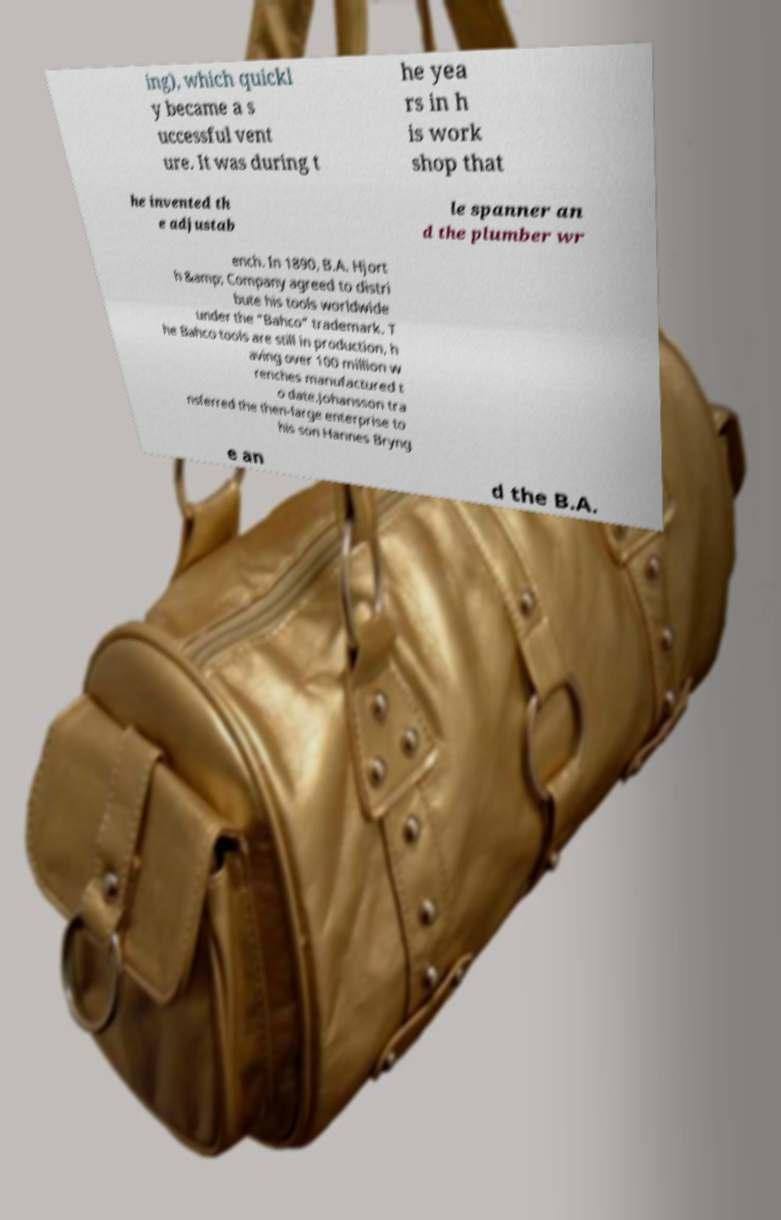Please identify and transcribe the text found in this image. ing), which quickl y became a s uccessful vent ure. It was during t he yea rs in h is work shop that he invented th e adjustab le spanner an d the plumber wr ench. In 1890, B.A. Hjort h &amp; Company agreed to distri bute his tools worldwide under the "Bahco" trademark. T he Bahco tools are still in production, h aving over 100 million w renches manufactured t o date.Johansson tra nsferred the then-large enterprise to his son Hannes Bryng e an d the B.A. 